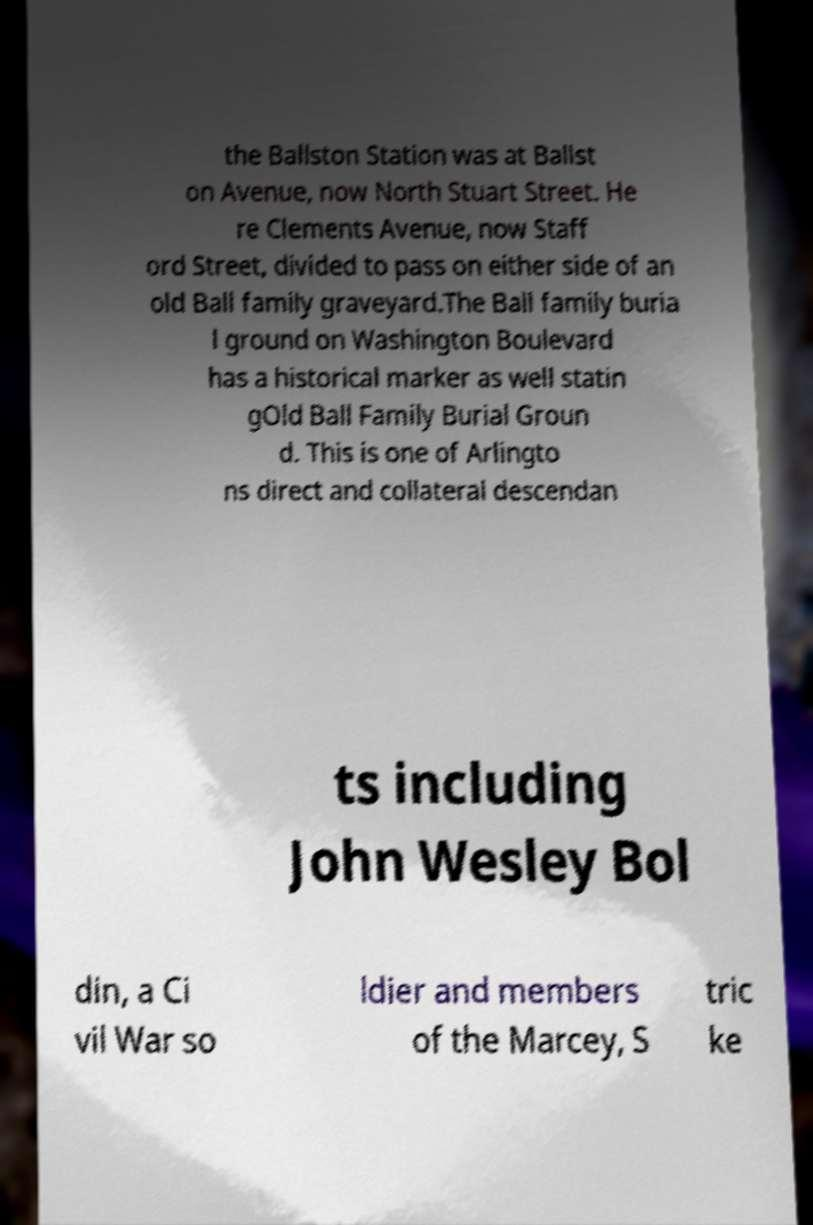Can you read and provide the text displayed in the image?This photo seems to have some interesting text. Can you extract and type it out for me? the Ballston Station was at Ballst on Avenue, now North Stuart Street. He re Clements Avenue, now Staff ord Street, divided to pass on either side of an old Ball family graveyard.The Ball family buria l ground on Washington Boulevard has a historical marker as well statin gOld Ball Family Burial Groun d. This is one of Arlingto ns direct and collateral descendan ts including John Wesley Bol din, a Ci vil War so ldier and members of the Marcey, S tric ke 